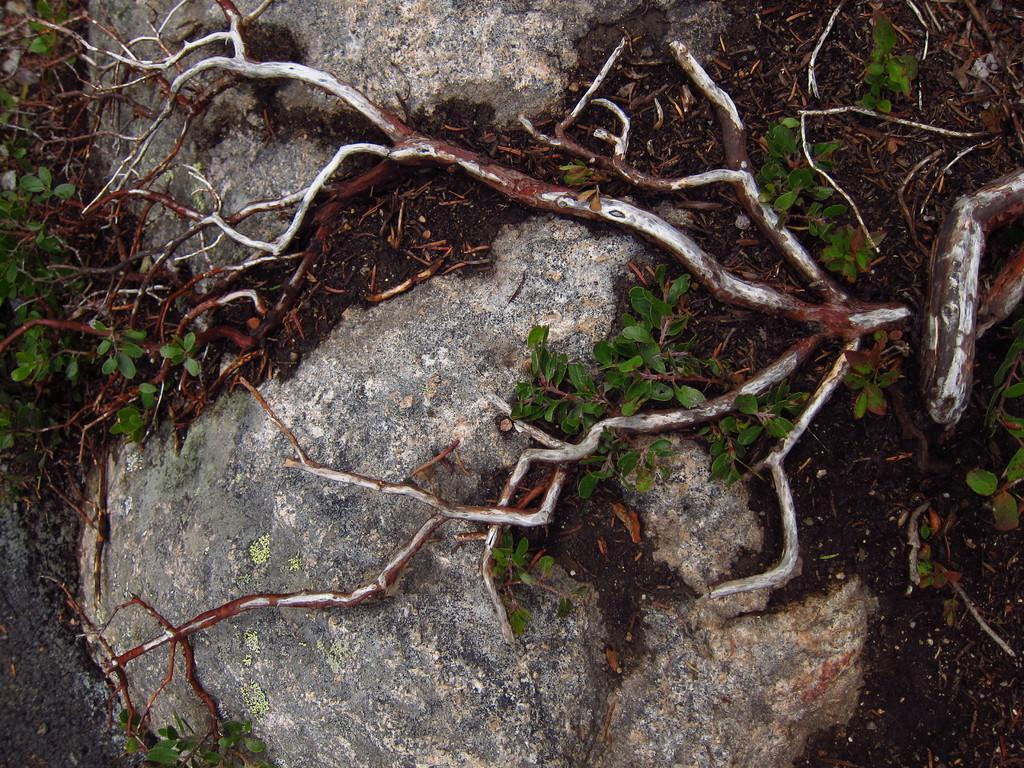In one or two sentences, can you explain what this image depicts? Here we can see roots of a tree on two stones and there are plants on the ground. 